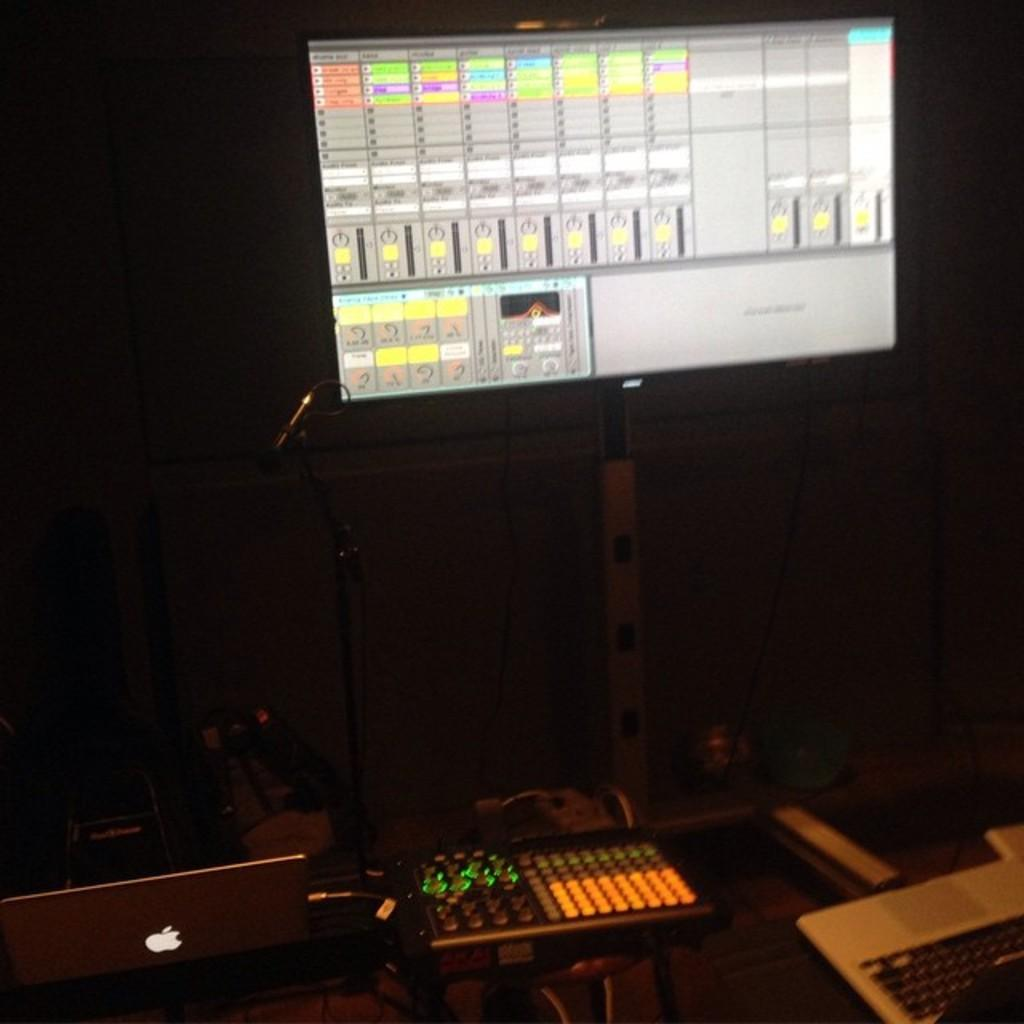What time of day was the image taken? The image was taken during night. What can be seen on the screen in the image? The content of the screen is not visible in the image. What objects are on the floor in the image? The nature of the objects on the floor is not specified in the facts. What is the central object in the image? There is a microphone (mike) in the middle of the image. What language is being spoken by the person holding the watch in the image? There is no person holding a watch in the image, and therefore no language can be identified. 